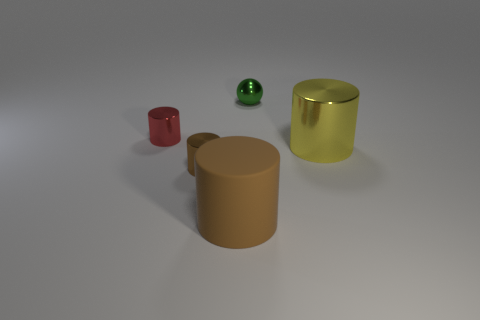Add 3 tiny brown metal cylinders. How many objects exist? 8 Subtract all large brown rubber cylinders. How many cylinders are left? 3 Subtract 1 cylinders. How many cylinders are left? 3 Subtract all red cylinders. How many cylinders are left? 3 Subtract all red cylinders. How many red spheres are left? 0 Subtract all large red metal blocks. Subtract all big cylinders. How many objects are left? 3 Add 4 metallic things. How many metallic things are left? 8 Add 1 red cylinders. How many red cylinders exist? 2 Subtract 0 cyan balls. How many objects are left? 5 Subtract all cylinders. How many objects are left? 1 